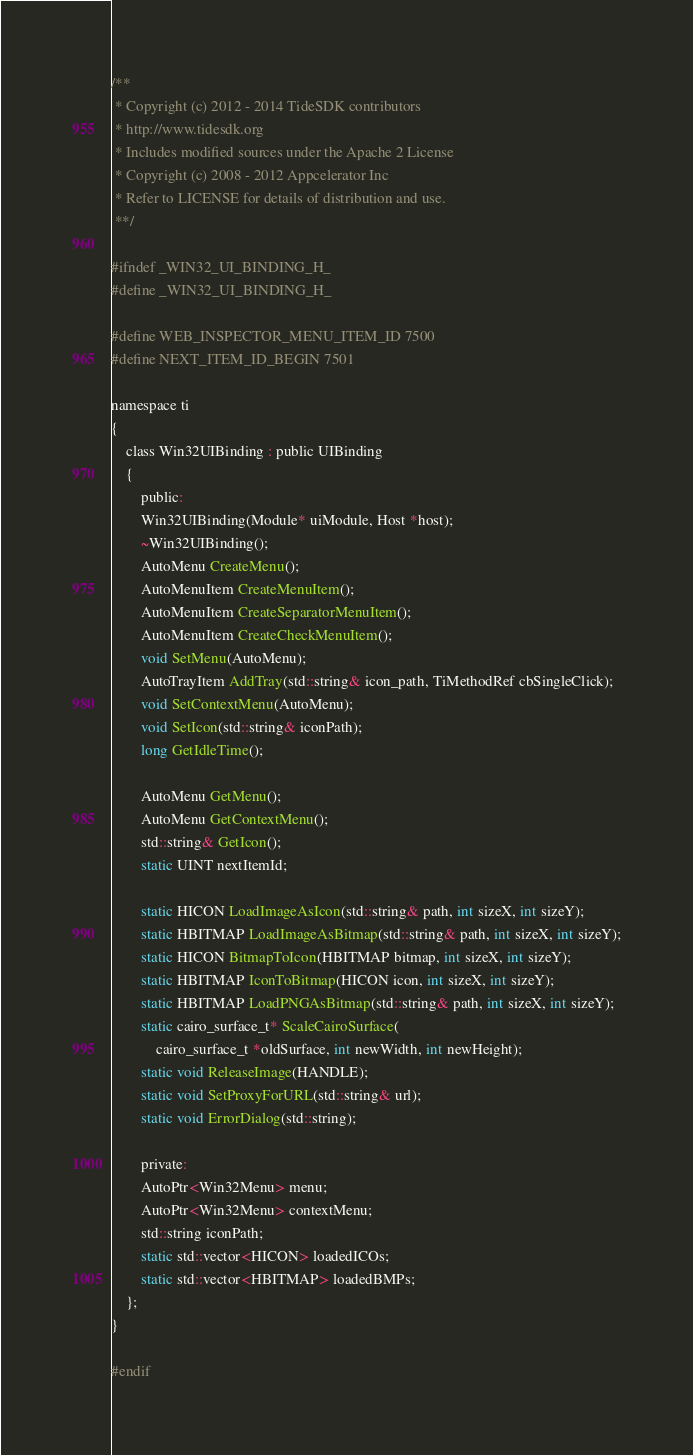Convert code to text. <code><loc_0><loc_0><loc_500><loc_500><_C_>/**
 * Copyright (c) 2012 - 2014 TideSDK contributors
 * http://www.tidesdk.org
 * Includes modified sources under the Apache 2 License
 * Copyright (c) 2008 - 2012 Appcelerator Inc
 * Refer to LICENSE for details of distribution and use.
 **/

#ifndef _WIN32_UI_BINDING_H_
#define _WIN32_UI_BINDING_H_

#define WEB_INSPECTOR_MENU_ITEM_ID 7500
#define NEXT_ITEM_ID_BEGIN 7501

namespace ti
{
    class Win32UIBinding : public UIBinding
    {
        public:
        Win32UIBinding(Module* uiModule, Host *host);
        ~Win32UIBinding();
        AutoMenu CreateMenu();
        AutoMenuItem CreateMenuItem();
        AutoMenuItem CreateSeparatorMenuItem();
        AutoMenuItem CreateCheckMenuItem();
        void SetMenu(AutoMenu);
        AutoTrayItem AddTray(std::string& icon_path, TiMethodRef cbSingleClick);
        void SetContextMenu(AutoMenu);
        void SetIcon(std::string& iconPath);
        long GetIdleTime();

        AutoMenu GetMenu();
        AutoMenu GetContextMenu();
        std::string& GetIcon();
        static UINT nextItemId;

        static HICON LoadImageAsIcon(std::string& path, int sizeX, int sizeY);
        static HBITMAP LoadImageAsBitmap(std::string& path, int sizeX, int sizeY);
        static HICON BitmapToIcon(HBITMAP bitmap, int sizeX, int sizeY);
        static HBITMAP IconToBitmap(HICON icon, int sizeX, int sizeY);
        static HBITMAP LoadPNGAsBitmap(std::string& path, int sizeX, int sizeY);
        static cairo_surface_t* ScaleCairoSurface(
            cairo_surface_t *oldSurface, int newWidth, int newHeight);
        static void ReleaseImage(HANDLE);
        static void SetProxyForURL(std::string& url);
        static void ErrorDialog(std::string);

        private:
        AutoPtr<Win32Menu> menu;
        AutoPtr<Win32Menu> contextMenu;
        std::string iconPath;
        static std::vector<HICON> loadedICOs;
        static std::vector<HBITMAP> loadedBMPs;
    };
}

#endif
</code> 